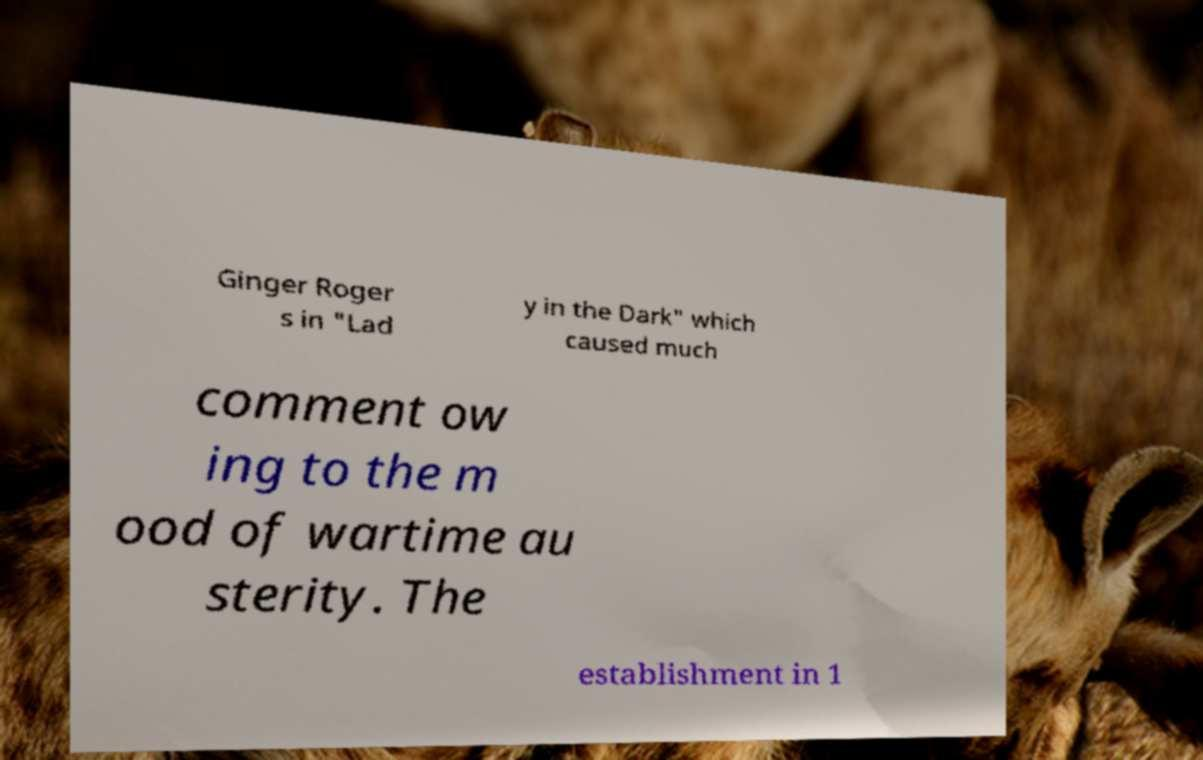There's text embedded in this image that I need extracted. Can you transcribe it verbatim? Ginger Roger s in "Lad y in the Dark" which caused much comment ow ing to the m ood of wartime au sterity. The establishment in 1 